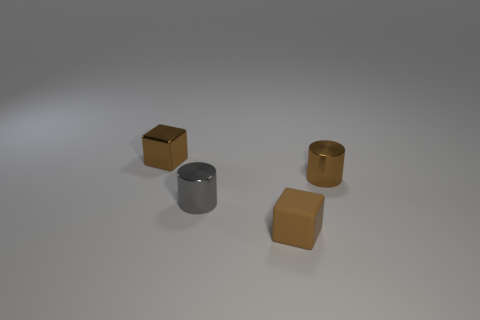Do these objects appear to be in natural or artificial light? The shadows cast by the objects and the overall lighting suggests that they are in an environment with artificial light. The light source seems to be above them, given the direction of the shadows. What can you infer about the setting from the lighting and arrangement of the objects? The controlled lighting and the deliberate placement of the objects suggest a setting that might be used for a display or a photograph, possibly in a studio or a curated interior environment. 